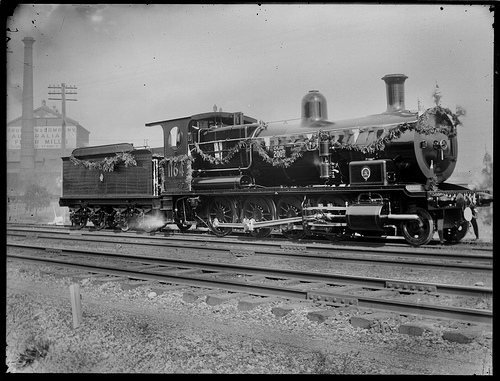Please transcribe the text information in this image. 1164 